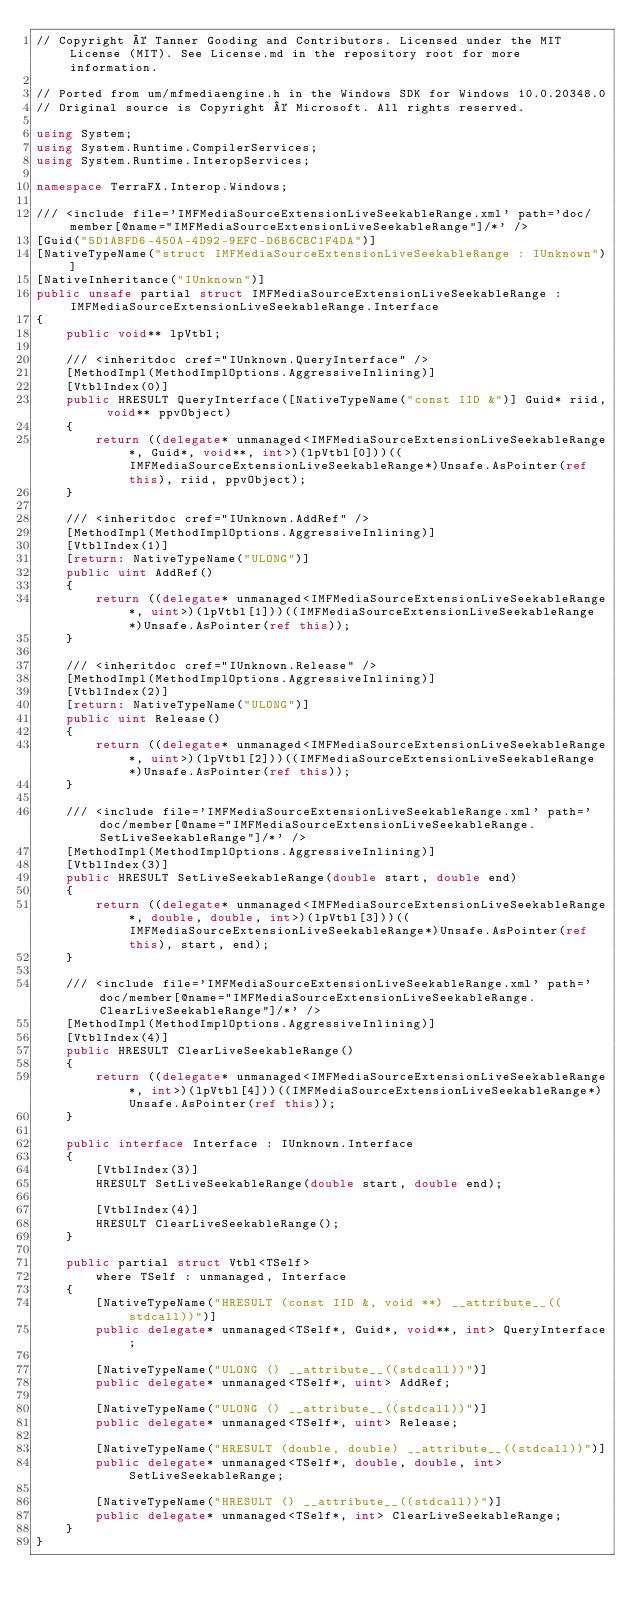Convert code to text. <code><loc_0><loc_0><loc_500><loc_500><_C#_>// Copyright © Tanner Gooding and Contributors. Licensed under the MIT License (MIT). See License.md in the repository root for more information.

// Ported from um/mfmediaengine.h in the Windows SDK for Windows 10.0.20348.0
// Original source is Copyright © Microsoft. All rights reserved.

using System;
using System.Runtime.CompilerServices;
using System.Runtime.InteropServices;

namespace TerraFX.Interop.Windows;

/// <include file='IMFMediaSourceExtensionLiveSeekableRange.xml' path='doc/member[@name="IMFMediaSourceExtensionLiveSeekableRange"]/*' />
[Guid("5D1ABFD6-450A-4D92-9EFC-D6B6CBC1F4DA")]
[NativeTypeName("struct IMFMediaSourceExtensionLiveSeekableRange : IUnknown")]
[NativeInheritance("IUnknown")]
public unsafe partial struct IMFMediaSourceExtensionLiveSeekableRange : IMFMediaSourceExtensionLiveSeekableRange.Interface
{
    public void** lpVtbl;

    /// <inheritdoc cref="IUnknown.QueryInterface" />
    [MethodImpl(MethodImplOptions.AggressiveInlining)]
    [VtblIndex(0)]
    public HRESULT QueryInterface([NativeTypeName("const IID &")] Guid* riid, void** ppvObject)
    {
        return ((delegate* unmanaged<IMFMediaSourceExtensionLiveSeekableRange*, Guid*, void**, int>)(lpVtbl[0]))((IMFMediaSourceExtensionLiveSeekableRange*)Unsafe.AsPointer(ref this), riid, ppvObject);
    }

    /// <inheritdoc cref="IUnknown.AddRef" />
    [MethodImpl(MethodImplOptions.AggressiveInlining)]
    [VtblIndex(1)]
    [return: NativeTypeName("ULONG")]
    public uint AddRef()
    {
        return ((delegate* unmanaged<IMFMediaSourceExtensionLiveSeekableRange*, uint>)(lpVtbl[1]))((IMFMediaSourceExtensionLiveSeekableRange*)Unsafe.AsPointer(ref this));
    }

    /// <inheritdoc cref="IUnknown.Release" />
    [MethodImpl(MethodImplOptions.AggressiveInlining)]
    [VtblIndex(2)]
    [return: NativeTypeName("ULONG")]
    public uint Release()
    {
        return ((delegate* unmanaged<IMFMediaSourceExtensionLiveSeekableRange*, uint>)(lpVtbl[2]))((IMFMediaSourceExtensionLiveSeekableRange*)Unsafe.AsPointer(ref this));
    }

    /// <include file='IMFMediaSourceExtensionLiveSeekableRange.xml' path='doc/member[@name="IMFMediaSourceExtensionLiveSeekableRange.SetLiveSeekableRange"]/*' />
    [MethodImpl(MethodImplOptions.AggressiveInlining)]
    [VtblIndex(3)]
    public HRESULT SetLiveSeekableRange(double start, double end)
    {
        return ((delegate* unmanaged<IMFMediaSourceExtensionLiveSeekableRange*, double, double, int>)(lpVtbl[3]))((IMFMediaSourceExtensionLiveSeekableRange*)Unsafe.AsPointer(ref this), start, end);
    }

    /// <include file='IMFMediaSourceExtensionLiveSeekableRange.xml' path='doc/member[@name="IMFMediaSourceExtensionLiveSeekableRange.ClearLiveSeekableRange"]/*' />
    [MethodImpl(MethodImplOptions.AggressiveInlining)]
    [VtblIndex(4)]
    public HRESULT ClearLiveSeekableRange()
    {
        return ((delegate* unmanaged<IMFMediaSourceExtensionLiveSeekableRange*, int>)(lpVtbl[4]))((IMFMediaSourceExtensionLiveSeekableRange*)Unsafe.AsPointer(ref this));
    }

    public interface Interface : IUnknown.Interface
    {
        [VtblIndex(3)]
        HRESULT SetLiveSeekableRange(double start, double end);

        [VtblIndex(4)]
        HRESULT ClearLiveSeekableRange();
    }

    public partial struct Vtbl<TSelf>
        where TSelf : unmanaged, Interface
    {
        [NativeTypeName("HRESULT (const IID &, void **) __attribute__((stdcall))")]
        public delegate* unmanaged<TSelf*, Guid*, void**, int> QueryInterface;

        [NativeTypeName("ULONG () __attribute__((stdcall))")]
        public delegate* unmanaged<TSelf*, uint> AddRef;

        [NativeTypeName("ULONG () __attribute__((stdcall))")]
        public delegate* unmanaged<TSelf*, uint> Release;

        [NativeTypeName("HRESULT (double, double) __attribute__((stdcall))")]
        public delegate* unmanaged<TSelf*, double, double, int> SetLiveSeekableRange;

        [NativeTypeName("HRESULT () __attribute__((stdcall))")]
        public delegate* unmanaged<TSelf*, int> ClearLiveSeekableRange;
    }
}
</code> 